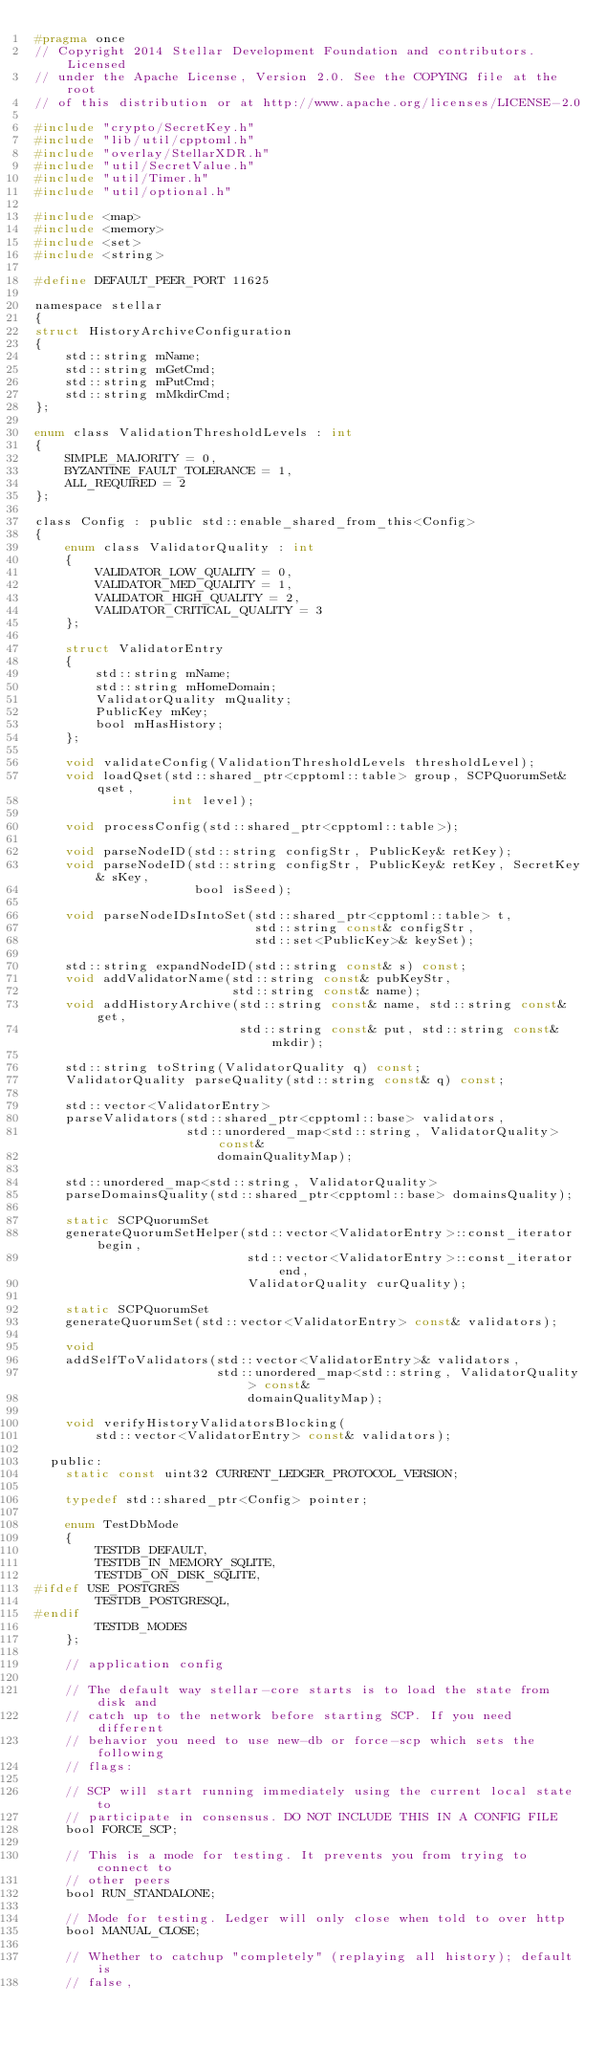<code> <loc_0><loc_0><loc_500><loc_500><_C_>#pragma once
// Copyright 2014 Stellar Development Foundation and contributors. Licensed
// under the Apache License, Version 2.0. See the COPYING file at the root
// of this distribution or at http://www.apache.org/licenses/LICENSE-2.0

#include "crypto/SecretKey.h"
#include "lib/util/cpptoml.h"
#include "overlay/StellarXDR.h"
#include "util/SecretValue.h"
#include "util/Timer.h"
#include "util/optional.h"

#include <map>
#include <memory>
#include <set>
#include <string>

#define DEFAULT_PEER_PORT 11625

namespace stellar
{
struct HistoryArchiveConfiguration
{
    std::string mName;
    std::string mGetCmd;
    std::string mPutCmd;
    std::string mMkdirCmd;
};

enum class ValidationThresholdLevels : int
{
    SIMPLE_MAJORITY = 0,
    BYZANTINE_FAULT_TOLERANCE = 1,
    ALL_REQUIRED = 2
};

class Config : public std::enable_shared_from_this<Config>
{
    enum class ValidatorQuality : int
    {
        VALIDATOR_LOW_QUALITY = 0,
        VALIDATOR_MED_QUALITY = 1,
        VALIDATOR_HIGH_QUALITY = 2,
        VALIDATOR_CRITICAL_QUALITY = 3
    };

    struct ValidatorEntry
    {
        std::string mName;
        std::string mHomeDomain;
        ValidatorQuality mQuality;
        PublicKey mKey;
        bool mHasHistory;
    };

    void validateConfig(ValidationThresholdLevels thresholdLevel);
    void loadQset(std::shared_ptr<cpptoml::table> group, SCPQuorumSet& qset,
                  int level);

    void processConfig(std::shared_ptr<cpptoml::table>);

    void parseNodeID(std::string configStr, PublicKey& retKey);
    void parseNodeID(std::string configStr, PublicKey& retKey, SecretKey& sKey,
                     bool isSeed);

    void parseNodeIDsIntoSet(std::shared_ptr<cpptoml::table> t,
                             std::string const& configStr,
                             std::set<PublicKey>& keySet);

    std::string expandNodeID(std::string const& s) const;
    void addValidatorName(std::string const& pubKeyStr,
                          std::string const& name);
    void addHistoryArchive(std::string const& name, std::string const& get,
                           std::string const& put, std::string const& mkdir);

    std::string toString(ValidatorQuality q) const;
    ValidatorQuality parseQuality(std::string const& q) const;

    std::vector<ValidatorEntry>
    parseValidators(std::shared_ptr<cpptoml::base> validators,
                    std::unordered_map<std::string, ValidatorQuality> const&
                        domainQualityMap);

    std::unordered_map<std::string, ValidatorQuality>
    parseDomainsQuality(std::shared_ptr<cpptoml::base> domainsQuality);

    static SCPQuorumSet
    generateQuorumSetHelper(std::vector<ValidatorEntry>::const_iterator begin,
                            std::vector<ValidatorEntry>::const_iterator end,
                            ValidatorQuality curQuality);

    static SCPQuorumSet
    generateQuorumSet(std::vector<ValidatorEntry> const& validators);

    void
    addSelfToValidators(std::vector<ValidatorEntry>& validators,
                        std::unordered_map<std::string, ValidatorQuality> const&
                            domainQualityMap);

    void verifyHistoryValidatorsBlocking(
        std::vector<ValidatorEntry> const& validators);

  public:
    static const uint32 CURRENT_LEDGER_PROTOCOL_VERSION;

    typedef std::shared_ptr<Config> pointer;

    enum TestDbMode
    {
        TESTDB_DEFAULT,
        TESTDB_IN_MEMORY_SQLITE,
        TESTDB_ON_DISK_SQLITE,
#ifdef USE_POSTGRES
        TESTDB_POSTGRESQL,
#endif
        TESTDB_MODES
    };

    // application config

    // The default way stellar-core starts is to load the state from disk and
    // catch up to the network before starting SCP. If you need different
    // behavior you need to use new-db or force-scp which sets the following
    // flags:

    // SCP will start running immediately using the current local state to
    // participate in consensus. DO NOT INCLUDE THIS IN A CONFIG FILE
    bool FORCE_SCP;

    // This is a mode for testing. It prevents you from trying to connect to
    // other peers
    bool RUN_STANDALONE;

    // Mode for testing. Ledger will only close when told to over http
    bool MANUAL_CLOSE;

    // Whether to catchup "completely" (replaying all history); default is
    // false,</code> 